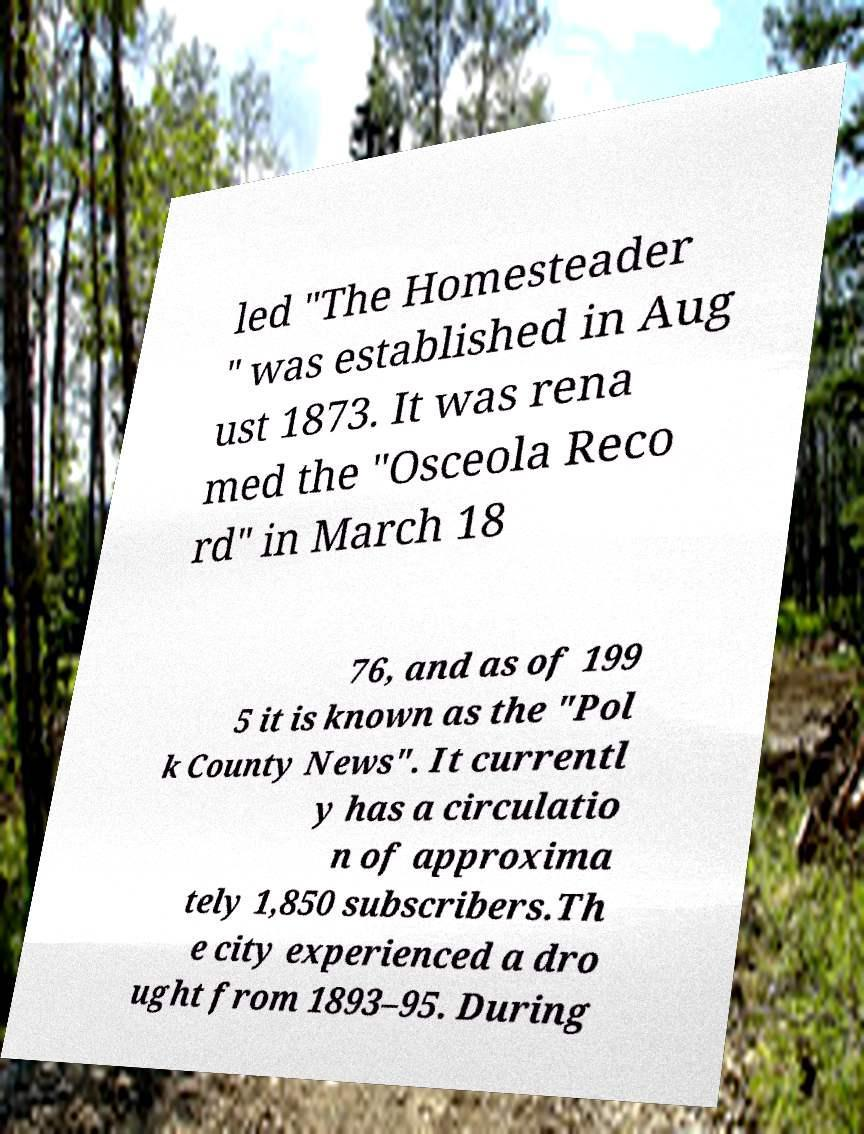There's text embedded in this image that I need extracted. Can you transcribe it verbatim? led "The Homesteader " was established in Aug ust 1873. It was rena med the "Osceola Reco rd" in March 18 76, and as of 199 5 it is known as the "Pol k County News". It currentl y has a circulatio n of approxima tely 1,850 subscribers.Th e city experienced a dro ught from 1893–95. During 